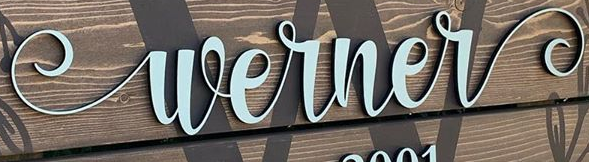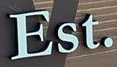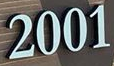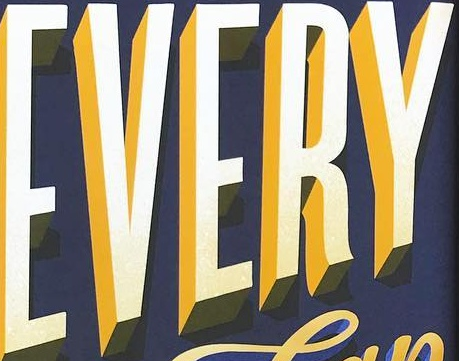Read the text content from these images in order, separated by a semicolon. Werner; Est.; 2001; EVERY 